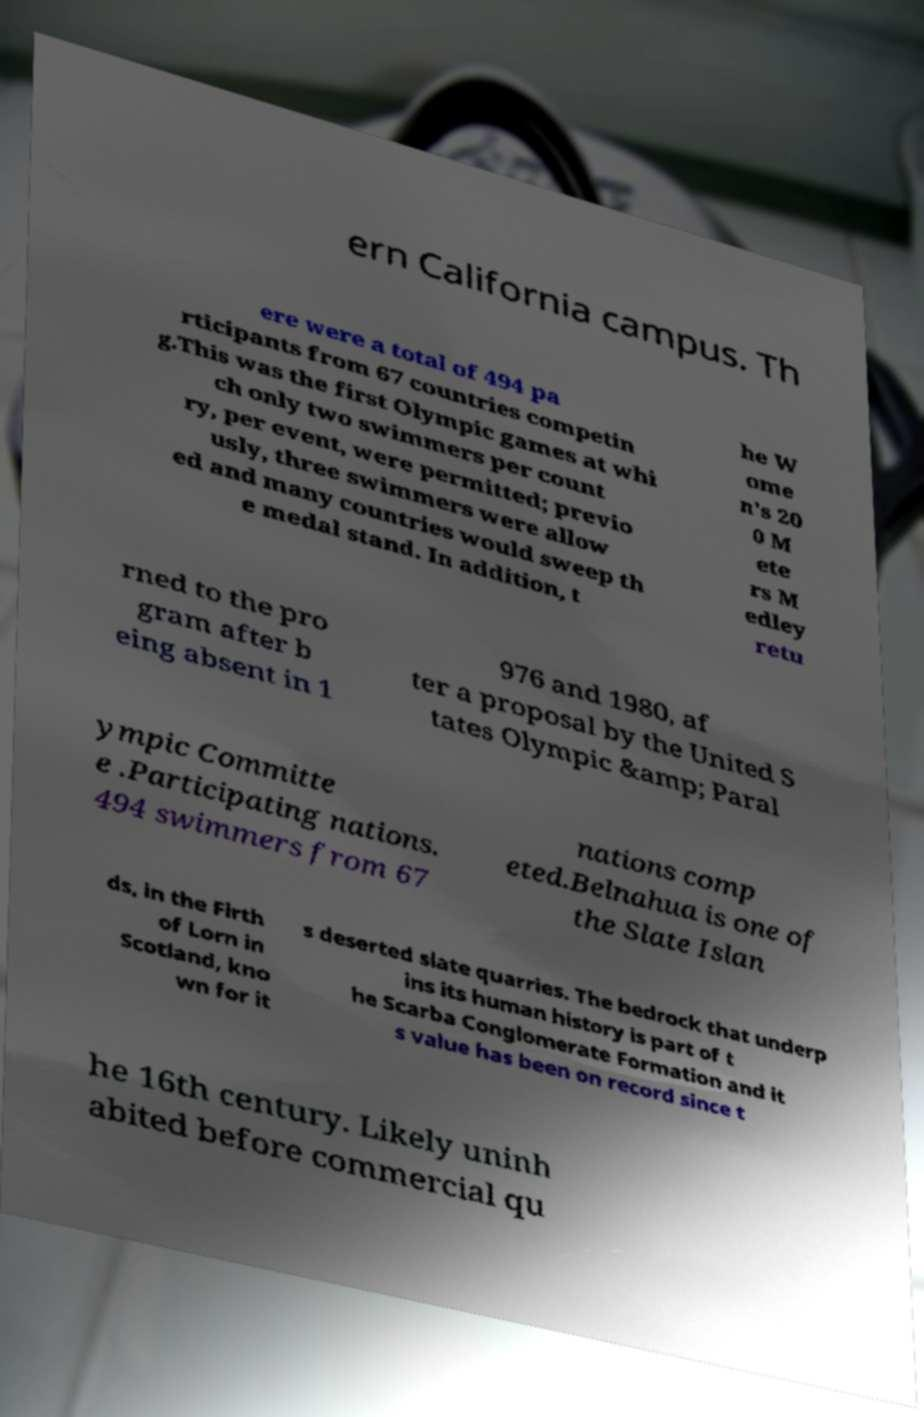There's text embedded in this image that I need extracted. Can you transcribe it verbatim? ern California campus. Th ere were a total of 494 pa rticipants from 67 countries competin g.This was the first Olympic games at whi ch only two swimmers per count ry, per event, were permitted; previo usly, three swimmers were allow ed and many countries would sweep th e medal stand. In addition, t he W ome n's 20 0 M ete rs M edley retu rned to the pro gram after b eing absent in 1 976 and 1980, af ter a proposal by the United S tates Olympic &amp; Paral ympic Committe e .Participating nations. 494 swimmers from 67 nations comp eted.Belnahua is one of the Slate Islan ds, in the Firth of Lorn in Scotland, kno wn for it s deserted slate quarries. The bedrock that underp ins its human history is part of t he Scarba Conglomerate Formation and it s value has been on record since t he 16th century. Likely uninh abited before commercial qu 